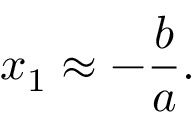Convert formula to latex. <formula><loc_0><loc_0><loc_500><loc_500>x _ { 1 } \approx - { \frac { b } { a } } .</formula> 